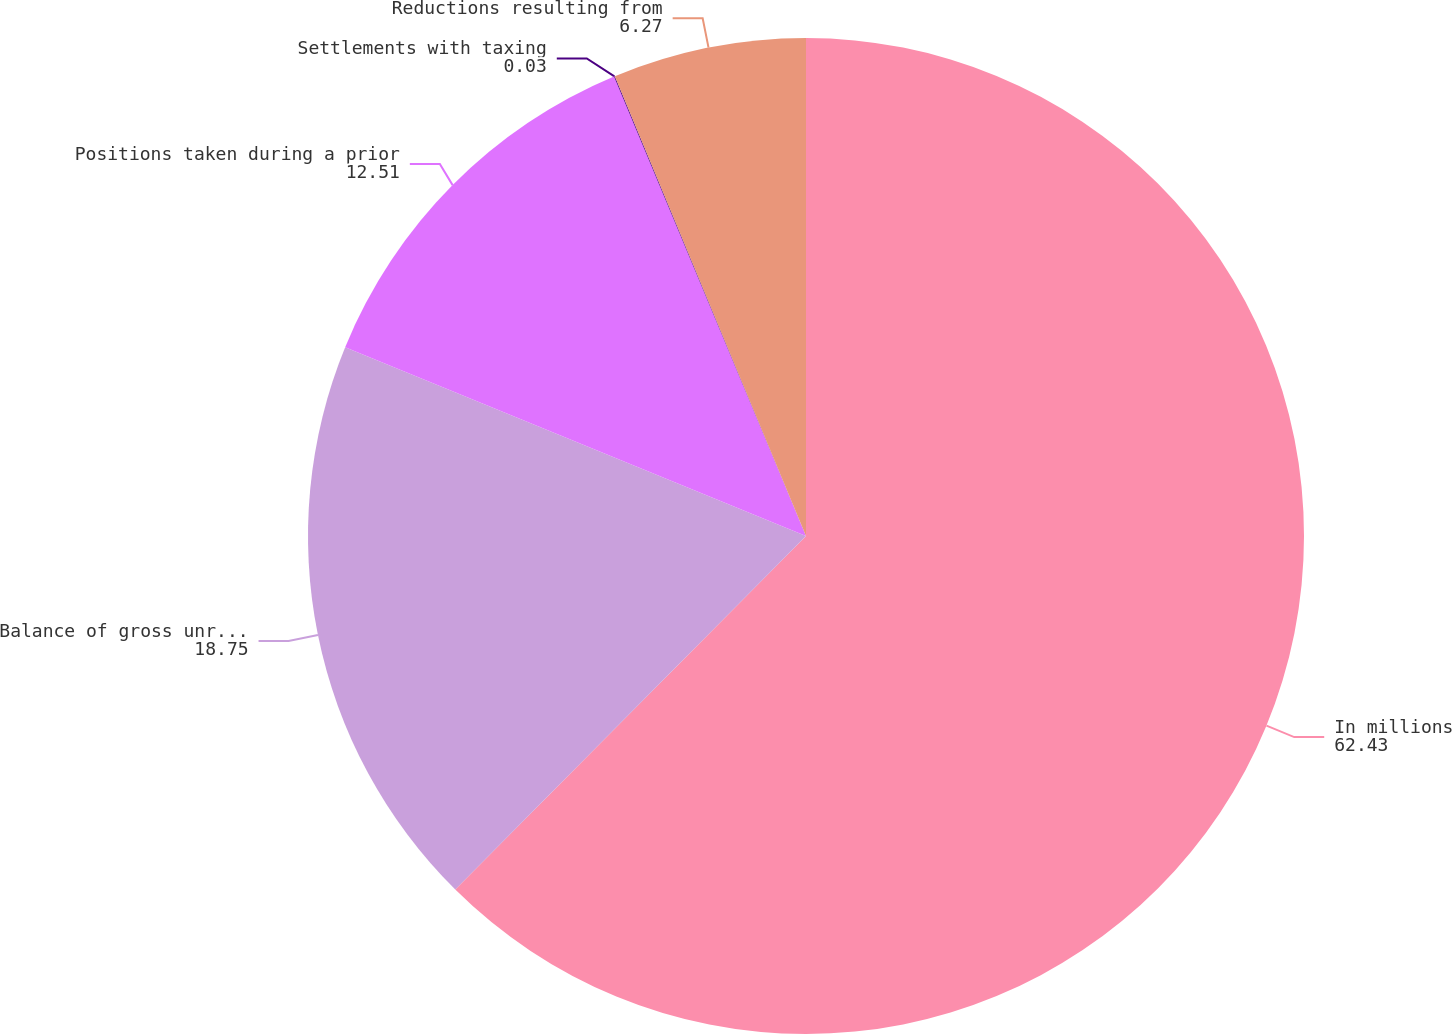<chart> <loc_0><loc_0><loc_500><loc_500><pie_chart><fcel>In millions<fcel>Balance of gross unrecognized<fcel>Positions taken during a prior<fcel>Settlements with taxing<fcel>Reductions resulting from<nl><fcel>62.43%<fcel>18.75%<fcel>12.51%<fcel>0.03%<fcel>6.27%<nl></chart> 